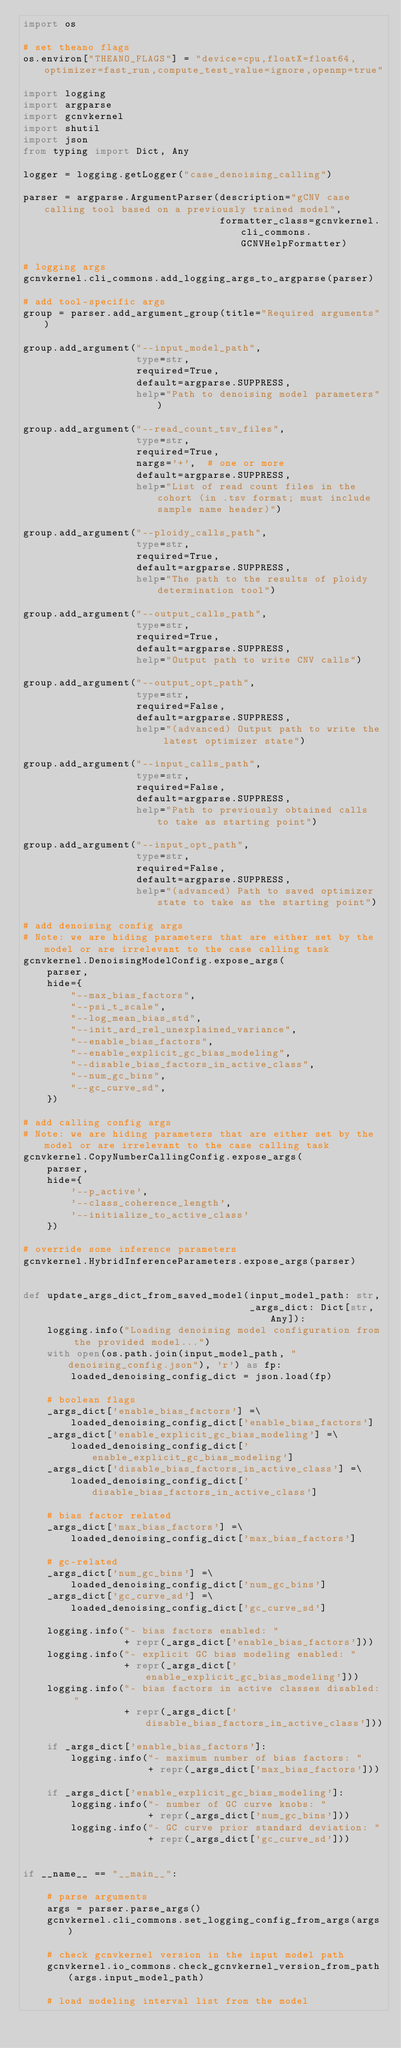Convert code to text. <code><loc_0><loc_0><loc_500><loc_500><_Python_>import os

# set theano flags
os.environ["THEANO_FLAGS"] = "device=cpu,floatX=float64,optimizer=fast_run,compute_test_value=ignore,openmp=true"

import logging
import argparse
import gcnvkernel
import shutil
import json
from typing import Dict, Any

logger = logging.getLogger("case_denoising_calling")

parser = argparse.ArgumentParser(description="gCNV case calling tool based on a previously trained model",
                                 formatter_class=gcnvkernel.cli_commons.GCNVHelpFormatter)

# logging args
gcnvkernel.cli_commons.add_logging_args_to_argparse(parser)

# add tool-specific args
group = parser.add_argument_group(title="Required arguments")

group.add_argument("--input_model_path",
                   type=str,
                   required=True,
                   default=argparse.SUPPRESS,
                   help="Path to denoising model parameters")

group.add_argument("--read_count_tsv_files",
                   type=str,
                   required=True,
                   nargs='+',  # one or more
                   default=argparse.SUPPRESS,
                   help="List of read count files in the cohort (in .tsv format; must include sample name header)")

group.add_argument("--ploidy_calls_path",
                   type=str,
                   required=True,
                   default=argparse.SUPPRESS,
                   help="The path to the results of ploidy determination tool")

group.add_argument("--output_calls_path",
                   type=str,
                   required=True,
                   default=argparse.SUPPRESS,
                   help="Output path to write CNV calls")

group.add_argument("--output_opt_path",
                   type=str,
                   required=False,
                   default=argparse.SUPPRESS,
                   help="(advanced) Output path to write the latest optimizer state")

group.add_argument("--input_calls_path",
                   type=str,
                   required=False,
                   default=argparse.SUPPRESS,
                   help="Path to previously obtained calls to take as starting point")

group.add_argument("--input_opt_path",
                   type=str,
                   required=False,
                   default=argparse.SUPPRESS,
                   help="(advanced) Path to saved optimizer state to take as the starting point")

# add denoising config args
# Note: we are hiding parameters that are either set by the model or are irrelevant to the case calling task
gcnvkernel.DenoisingModelConfig.expose_args(
    parser,
    hide={
        "--max_bias_factors",
        "--psi_t_scale",
        "--log_mean_bias_std",
        "--init_ard_rel_unexplained_variance",
        "--enable_bias_factors",
        "--enable_explicit_gc_bias_modeling",
        "--disable_bias_factors_in_active_class",
        "--num_gc_bins",
        "--gc_curve_sd",
    })

# add calling config args
# Note: we are hiding parameters that are either set by the model or are irrelevant to the case calling task
gcnvkernel.CopyNumberCallingConfig.expose_args(
    parser,
    hide={
        '--p_active',
        '--class_coherence_length',
        '--initialize_to_active_class'
    })

# override some inference parameters
gcnvkernel.HybridInferenceParameters.expose_args(parser)


def update_args_dict_from_saved_model(input_model_path: str,
                                      _args_dict: Dict[str, Any]):
    logging.info("Loading denoising model configuration from the provided model...")
    with open(os.path.join(input_model_path, "denoising_config.json"), 'r') as fp:
        loaded_denoising_config_dict = json.load(fp)

    # boolean flags
    _args_dict['enable_bias_factors'] =\
        loaded_denoising_config_dict['enable_bias_factors']
    _args_dict['enable_explicit_gc_bias_modeling'] =\
        loaded_denoising_config_dict['enable_explicit_gc_bias_modeling']
    _args_dict['disable_bias_factors_in_active_class'] =\
        loaded_denoising_config_dict['disable_bias_factors_in_active_class']

    # bias factor related
    _args_dict['max_bias_factors'] =\
        loaded_denoising_config_dict['max_bias_factors']

    # gc-related
    _args_dict['num_gc_bins'] =\
        loaded_denoising_config_dict['num_gc_bins']
    _args_dict['gc_curve_sd'] =\
        loaded_denoising_config_dict['gc_curve_sd']

    logging.info("- bias factors enabled: "
                 + repr(_args_dict['enable_bias_factors']))
    logging.info("- explicit GC bias modeling enabled: "
                 + repr(_args_dict['enable_explicit_gc_bias_modeling']))
    logging.info("- bias factors in active classes disabled: "
                 + repr(_args_dict['disable_bias_factors_in_active_class']))

    if _args_dict['enable_bias_factors']:
        logging.info("- maximum number of bias factors: "
                     + repr(_args_dict['max_bias_factors']))

    if _args_dict['enable_explicit_gc_bias_modeling']:
        logging.info("- number of GC curve knobs: "
                     + repr(_args_dict['num_gc_bins']))
        logging.info("- GC curve prior standard deviation: "
                     + repr(_args_dict['gc_curve_sd']))


if __name__ == "__main__":

    # parse arguments
    args = parser.parse_args()
    gcnvkernel.cli_commons.set_logging_config_from_args(args)

    # check gcnvkernel version in the input model path
    gcnvkernel.io_commons.check_gcnvkernel_version_from_path(args.input_model_path)

    # load modeling interval list from the model</code> 